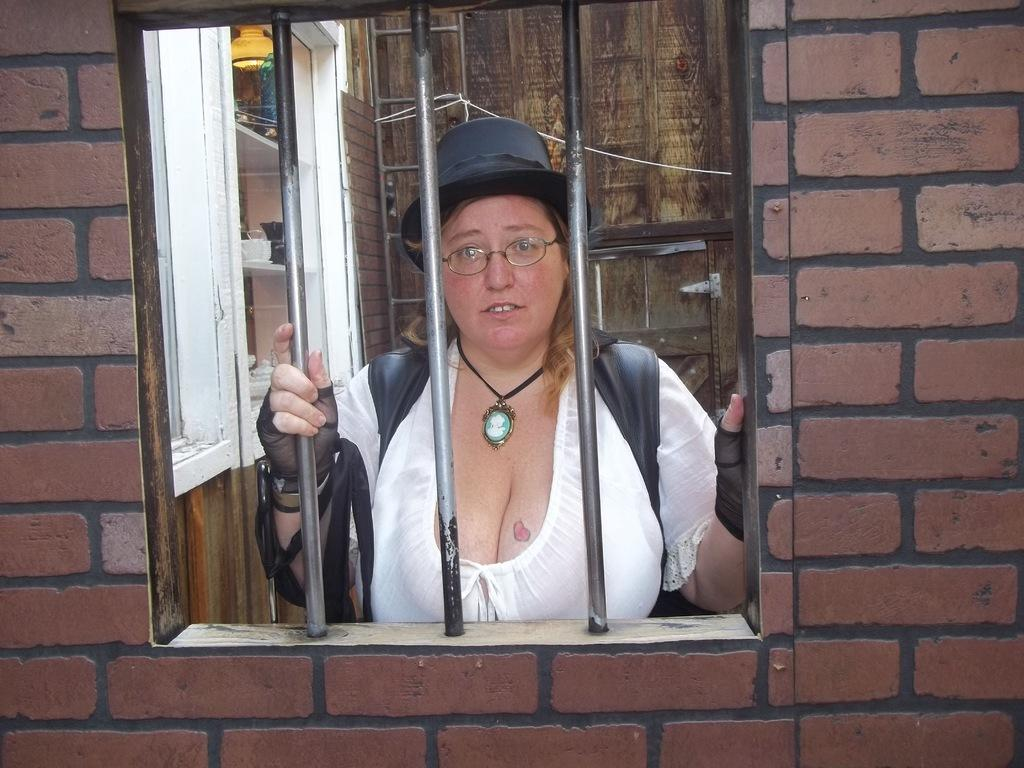Who is present in the image? There is a woman in the image. What is the woman wearing? The woman is wearing a white dress and a hat. What can be seen on the wall in the image? There is a window in the wall. What object is visible in the image that might be used for climbing? There is a ladder visible in the image. What type of thrill can be experienced by the person in the image? There is no person experiencing a thrill in the image, as the text only mentions a woman wearing a white dress and a hat. 